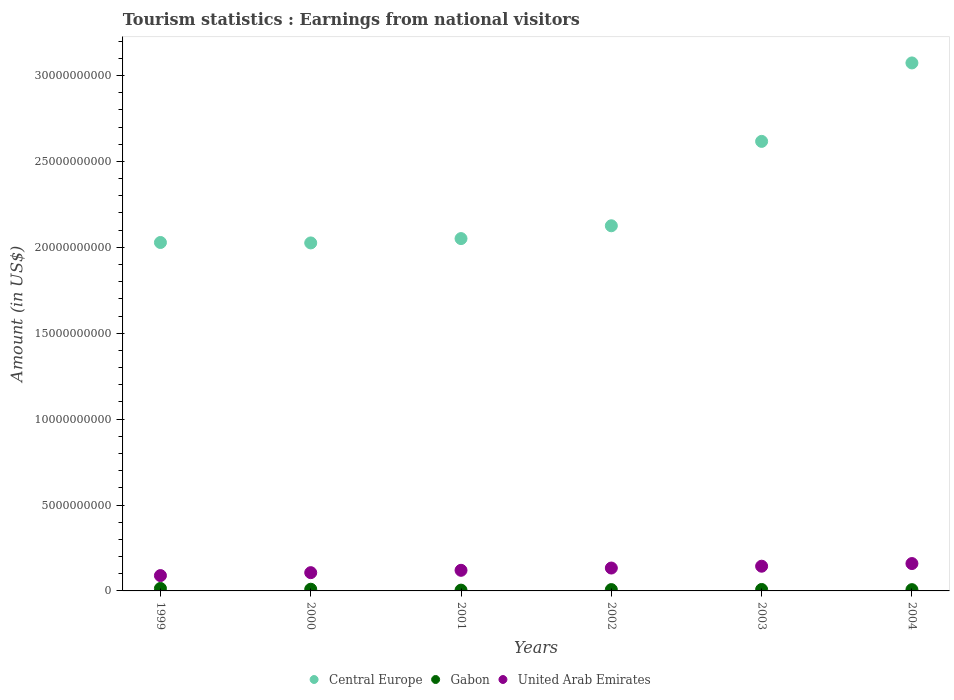What is the earnings from national visitors in Central Europe in 2000?
Make the answer very short. 2.03e+1. Across all years, what is the maximum earnings from national visitors in United Arab Emirates?
Make the answer very short. 1.59e+09. Across all years, what is the minimum earnings from national visitors in Gabon?
Give a very brief answer. 4.60e+07. In which year was the earnings from national visitors in Central Europe maximum?
Give a very brief answer. 2004. What is the total earnings from national visitors in Gabon in the graph?
Your answer should be compact. 5.23e+08. What is the difference between the earnings from national visitors in United Arab Emirates in 2001 and that in 2004?
Provide a succinct answer. -3.93e+08. What is the difference between the earnings from national visitors in Central Europe in 2004 and the earnings from national visitors in United Arab Emirates in 2002?
Provide a succinct answer. 2.94e+1. What is the average earnings from national visitors in Gabon per year?
Offer a very short reply. 8.72e+07. In the year 2002, what is the difference between the earnings from national visitors in Gabon and earnings from national visitors in Central Europe?
Keep it short and to the point. -2.12e+1. What is the ratio of the earnings from national visitors in Central Europe in 2000 to that in 2001?
Give a very brief answer. 0.99. Is the earnings from national visitors in Central Europe in 2000 less than that in 2003?
Your answer should be very brief. Yes. Is the difference between the earnings from national visitors in Gabon in 1999 and 2001 greater than the difference between the earnings from national visitors in Central Europe in 1999 and 2001?
Your response must be concise. Yes. What is the difference between the highest and the second highest earnings from national visitors in Gabon?
Offer a very short reply. 4.40e+07. What is the difference between the highest and the lowest earnings from national visitors in United Arab Emirates?
Your answer should be very brief. 7.00e+08. In how many years, is the earnings from national visitors in Gabon greater than the average earnings from national visitors in Gabon taken over all years?
Give a very brief answer. 2. Is the sum of the earnings from national visitors in Gabon in 2003 and 2004 greater than the maximum earnings from national visitors in Central Europe across all years?
Offer a very short reply. No. Is the earnings from national visitors in Central Europe strictly less than the earnings from national visitors in United Arab Emirates over the years?
Provide a succinct answer. No. How many years are there in the graph?
Ensure brevity in your answer.  6. Are the values on the major ticks of Y-axis written in scientific E-notation?
Make the answer very short. No. How are the legend labels stacked?
Offer a terse response. Horizontal. What is the title of the graph?
Offer a terse response. Tourism statistics : Earnings from national visitors. Does "Fiji" appear as one of the legend labels in the graph?
Give a very brief answer. No. What is the Amount (in US$) of Central Europe in 1999?
Your answer should be compact. 2.03e+1. What is the Amount (in US$) in Gabon in 1999?
Your response must be concise. 1.43e+08. What is the Amount (in US$) of United Arab Emirates in 1999?
Keep it short and to the point. 8.93e+08. What is the Amount (in US$) in Central Europe in 2000?
Make the answer very short. 2.03e+1. What is the Amount (in US$) in Gabon in 2000?
Your answer should be very brief. 9.90e+07. What is the Amount (in US$) in United Arab Emirates in 2000?
Your answer should be compact. 1.06e+09. What is the Amount (in US$) of Central Europe in 2001?
Ensure brevity in your answer.  2.05e+1. What is the Amount (in US$) in Gabon in 2001?
Give a very brief answer. 4.60e+07. What is the Amount (in US$) of United Arab Emirates in 2001?
Your response must be concise. 1.20e+09. What is the Amount (in US$) of Central Europe in 2002?
Your answer should be very brief. 2.13e+1. What is the Amount (in US$) in Gabon in 2002?
Provide a short and direct response. 7.70e+07. What is the Amount (in US$) in United Arab Emirates in 2002?
Provide a succinct answer. 1.33e+09. What is the Amount (in US$) in Central Europe in 2003?
Offer a very short reply. 2.62e+1. What is the Amount (in US$) of Gabon in 2003?
Give a very brief answer. 8.40e+07. What is the Amount (in US$) in United Arab Emirates in 2003?
Your response must be concise. 1.44e+09. What is the Amount (in US$) of Central Europe in 2004?
Your answer should be very brief. 3.07e+1. What is the Amount (in US$) in Gabon in 2004?
Your answer should be very brief. 7.40e+07. What is the Amount (in US$) of United Arab Emirates in 2004?
Your answer should be very brief. 1.59e+09. Across all years, what is the maximum Amount (in US$) in Central Europe?
Make the answer very short. 3.07e+1. Across all years, what is the maximum Amount (in US$) in Gabon?
Offer a terse response. 1.43e+08. Across all years, what is the maximum Amount (in US$) of United Arab Emirates?
Keep it short and to the point. 1.59e+09. Across all years, what is the minimum Amount (in US$) in Central Europe?
Your response must be concise. 2.03e+1. Across all years, what is the minimum Amount (in US$) in Gabon?
Ensure brevity in your answer.  4.60e+07. Across all years, what is the minimum Amount (in US$) of United Arab Emirates?
Provide a succinct answer. 8.93e+08. What is the total Amount (in US$) of Central Europe in the graph?
Give a very brief answer. 1.39e+11. What is the total Amount (in US$) of Gabon in the graph?
Ensure brevity in your answer.  5.23e+08. What is the total Amount (in US$) of United Arab Emirates in the graph?
Ensure brevity in your answer.  7.52e+09. What is the difference between the Amount (in US$) in Central Europe in 1999 and that in 2000?
Ensure brevity in your answer.  2.50e+07. What is the difference between the Amount (in US$) of Gabon in 1999 and that in 2000?
Your answer should be compact. 4.40e+07. What is the difference between the Amount (in US$) in United Arab Emirates in 1999 and that in 2000?
Offer a terse response. -1.70e+08. What is the difference between the Amount (in US$) in Central Europe in 1999 and that in 2001?
Provide a succinct answer. -2.27e+08. What is the difference between the Amount (in US$) of Gabon in 1999 and that in 2001?
Provide a short and direct response. 9.70e+07. What is the difference between the Amount (in US$) in United Arab Emirates in 1999 and that in 2001?
Provide a short and direct response. -3.07e+08. What is the difference between the Amount (in US$) in Central Europe in 1999 and that in 2002?
Your answer should be compact. -9.73e+08. What is the difference between the Amount (in US$) of Gabon in 1999 and that in 2002?
Provide a succinct answer. 6.60e+07. What is the difference between the Amount (in US$) of United Arab Emirates in 1999 and that in 2002?
Your answer should be compact. -4.39e+08. What is the difference between the Amount (in US$) in Central Europe in 1999 and that in 2003?
Your response must be concise. -5.88e+09. What is the difference between the Amount (in US$) of Gabon in 1999 and that in 2003?
Offer a very short reply. 5.90e+07. What is the difference between the Amount (in US$) of United Arab Emirates in 1999 and that in 2003?
Make the answer very short. -5.45e+08. What is the difference between the Amount (in US$) of Central Europe in 1999 and that in 2004?
Your answer should be compact. -1.05e+1. What is the difference between the Amount (in US$) of Gabon in 1999 and that in 2004?
Provide a succinct answer. 6.90e+07. What is the difference between the Amount (in US$) in United Arab Emirates in 1999 and that in 2004?
Provide a short and direct response. -7.00e+08. What is the difference between the Amount (in US$) of Central Europe in 2000 and that in 2001?
Keep it short and to the point. -2.52e+08. What is the difference between the Amount (in US$) in Gabon in 2000 and that in 2001?
Your answer should be very brief. 5.30e+07. What is the difference between the Amount (in US$) in United Arab Emirates in 2000 and that in 2001?
Ensure brevity in your answer.  -1.37e+08. What is the difference between the Amount (in US$) of Central Europe in 2000 and that in 2002?
Provide a short and direct response. -9.98e+08. What is the difference between the Amount (in US$) of Gabon in 2000 and that in 2002?
Give a very brief answer. 2.20e+07. What is the difference between the Amount (in US$) in United Arab Emirates in 2000 and that in 2002?
Keep it short and to the point. -2.69e+08. What is the difference between the Amount (in US$) in Central Europe in 2000 and that in 2003?
Make the answer very short. -5.91e+09. What is the difference between the Amount (in US$) of Gabon in 2000 and that in 2003?
Provide a succinct answer. 1.50e+07. What is the difference between the Amount (in US$) of United Arab Emirates in 2000 and that in 2003?
Provide a succinct answer. -3.75e+08. What is the difference between the Amount (in US$) of Central Europe in 2000 and that in 2004?
Provide a short and direct response. -1.05e+1. What is the difference between the Amount (in US$) in Gabon in 2000 and that in 2004?
Your response must be concise. 2.50e+07. What is the difference between the Amount (in US$) in United Arab Emirates in 2000 and that in 2004?
Your answer should be very brief. -5.30e+08. What is the difference between the Amount (in US$) in Central Europe in 2001 and that in 2002?
Make the answer very short. -7.46e+08. What is the difference between the Amount (in US$) in Gabon in 2001 and that in 2002?
Your answer should be compact. -3.10e+07. What is the difference between the Amount (in US$) of United Arab Emirates in 2001 and that in 2002?
Offer a very short reply. -1.32e+08. What is the difference between the Amount (in US$) of Central Europe in 2001 and that in 2003?
Make the answer very short. -5.66e+09. What is the difference between the Amount (in US$) of Gabon in 2001 and that in 2003?
Provide a succinct answer. -3.80e+07. What is the difference between the Amount (in US$) of United Arab Emirates in 2001 and that in 2003?
Offer a terse response. -2.38e+08. What is the difference between the Amount (in US$) of Central Europe in 2001 and that in 2004?
Keep it short and to the point. -1.02e+1. What is the difference between the Amount (in US$) of Gabon in 2001 and that in 2004?
Ensure brevity in your answer.  -2.80e+07. What is the difference between the Amount (in US$) of United Arab Emirates in 2001 and that in 2004?
Your answer should be very brief. -3.93e+08. What is the difference between the Amount (in US$) of Central Europe in 2002 and that in 2003?
Offer a very short reply. -4.91e+09. What is the difference between the Amount (in US$) of Gabon in 2002 and that in 2003?
Keep it short and to the point. -7.00e+06. What is the difference between the Amount (in US$) of United Arab Emirates in 2002 and that in 2003?
Give a very brief answer. -1.06e+08. What is the difference between the Amount (in US$) in Central Europe in 2002 and that in 2004?
Offer a terse response. -9.48e+09. What is the difference between the Amount (in US$) in Gabon in 2002 and that in 2004?
Make the answer very short. 3.00e+06. What is the difference between the Amount (in US$) in United Arab Emirates in 2002 and that in 2004?
Offer a very short reply. -2.61e+08. What is the difference between the Amount (in US$) in Central Europe in 2003 and that in 2004?
Your answer should be compact. -4.57e+09. What is the difference between the Amount (in US$) in United Arab Emirates in 2003 and that in 2004?
Your response must be concise. -1.55e+08. What is the difference between the Amount (in US$) in Central Europe in 1999 and the Amount (in US$) in Gabon in 2000?
Your response must be concise. 2.02e+1. What is the difference between the Amount (in US$) of Central Europe in 1999 and the Amount (in US$) of United Arab Emirates in 2000?
Offer a terse response. 1.92e+1. What is the difference between the Amount (in US$) in Gabon in 1999 and the Amount (in US$) in United Arab Emirates in 2000?
Make the answer very short. -9.20e+08. What is the difference between the Amount (in US$) of Central Europe in 1999 and the Amount (in US$) of Gabon in 2001?
Keep it short and to the point. 2.02e+1. What is the difference between the Amount (in US$) of Central Europe in 1999 and the Amount (in US$) of United Arab Emirates in 2001?
Offer a very short reply. 1.91e+1. What is the difference between the Amount (in US$) in Gabon in 1999 and the Amount (in US$) in United Arab Emirates in 2001?
Provide a short and direct response. -1.06e+09. What is the difference between the Amount (in US$) of Central Europe in 1999 and the Amount (in US$) of Gabon in 2002?
Make the answer very short. 2.02e+1. What is the difference between the Amount (in US$) in Central Europe in 1999 and the Amount (in US$) in United Arab Emirates in 2002?
Provide a succinct answer. 1.89e+1. What is the difference between the Amount (in US$) in Gabon in 1999 and the Amount (in US$) in United Arab Emirates in 2002?
Keep it short and to the point. -1.19e+09. What is the difference between the Amount (in US$) of Central Europe in 1999 and the Amount (in US$) of Gabon in 2003?
Make the answer very short. 2.02e+1. What is the difference between the Amount (in US$) of Central Europe in 1999 and the Amount (in US$) of United Arab Emirates in 2003?
Your answer should be very brief. 1.88e+1. What is the difference between the Amount (in US$) in Gabon in 1999 and the Amount (in US$) in United Arab Emirates in 2003?
Provide a short and direct response. -1.30e+09. What is the difference between the Amount (in US$) in Central Europe in 1999 and the Amount (in US$) in Gabon in 2004?
Give a very brief answer. 2.02e+1. What is the difference between the Amount (in US$) in Central Europe in 1999 and the Amount (in US$) in United Arab Emirates in 2004?
Provide a succinct answer. 1.87e+1. What is the difference between the Amount (in US$) of Gabon in 1999 and the Amount (in US$) of United Arab Emirates in 2004?
Provide a short and direct response. -1.45e+09. What is the difference between the Amount (in US$) in Central Europe in 2000 and the Amount (in US$) in Gabon in 2001?
Provide a short and direct response. 2.02e+1. What is the difference between the Amount (in US$) in Central Europe in 2000 and the Amount (in US$) in United Arab Emirates in 2001?
Your answer should be compact. 1.91e+1. What is the difference between the Amount (in US$) of Gabon in 2000 and the Amount (in US$) of United Arab Emirates in 2001?
Provide a short and direct response. -1.10e+09. What is the difference between the Amount (in US$) of Central Europe in 2000 and the Amount (in US$) of Gabon in 2002?
Your answer should be compact. 2.02e+1. What is the difference between the Amount (in US$) in Central Europe in 2000 and the Amount (in US$) in United Arab Emirates in 2002?
Offer a very short reply. 1.89e+1. What is the difference between the Amount (in US$) of Gabon in 2000 and the Amount (in US$) of United Arab Emirates in 2002?
Your answer should be very brief. -1.23e+09. What is the difference between the Amount (in US$) of Central Europe in 2000 and the Amount (in US$) of Gabon in 2003?
Your response must be concise. 2.02e+1. What is the difference between the Amount (in US$) in Central Europe in 2000 and the Amount (in US$) in United Arab Emirates in 2003?
Provide a succinct answer. 1.88e+1. What is the difference between the Amount (in US$) in Gabon in 2000 and the Amount (in US$) in United Arab Emirates in 2003?
Offer a very short reply. -1.34e+09. What is the difference between the Amount (in US$) in Central Europe in 2000 and the Amount (in US$) in Gabon in 2004?
Provide a short and direct response. 2.02e+1. What is the difference between the Amount (in US$) of Central Europe in 2000 and the Amount (in US$) of United Arab Emirates in 2004?
Make the answer very short. 1.87e+1. What is the difference between the Amount (in US$) in Gabon in 2000 and the Amount (in US$) in United Arab Emirates in 2004?
Provide a short and direct response. -1.49e+09. What is the difference between the Amount (in US$) in Central Europe in 2001 and the Amount (in US$) in Gabon in 2002?
Provide a succinct answer. 2.04e+1. What is the difference between the Amount (in US$) of Central Europe in 2001 and the Amount (in US$) of United Arab Emirates in 2002?
Provide a succinct answer. 1.92e+1. What is the difference between the Amount (in US$) of Gabon in 2001 and the Amount (in US$) of United Arab Emirates in 2002?
Offer a terse response. -1.29e+09. What is the difference between the Amount (in US$) of Central Europe in 2001 and the Amount (in US$) of Gabon in 2003?
Your response must be concise. 2.04e+1. What is the difference between the Amount (in US$) of Central Europe in 2001 and the Amount (in US$) of United Arab Emirates in 2003?
Offer a terse response. 1.91e+1. What is the difference between the Amount (in US$) of Gabon in 2001 and the Amount (in US$) of United Arab Emirates in 2003?
Make the answer very short. -1.39e+09. What is the difference between the Amount (in US$) of Central Europe in 2001 and the Amount (in US$) of Gabon in 2004?
Provide a short and direct response. 2.04e+1. What is the difference between the Amount (in US$) in Central Europe in 2001 and the Amount (in US$) in United Arab Emirates in 2004?
Ensure brevity in your answer.  1.89e+1. What is the difference between the Amount (in US$) of Gabon in 2001 and the Amount (in US$) of United Arab Emirates in 2004?
Make the answer very short. -1.55e+09. What is the difference between the Amount (in US$) of Central Europe in 2002 and the Amount (in US$) of Gabon in 2003?
Ensure brevity in your answer.  2.12e+1. What is the difference between the Amount (in US$) of Central Europe in 2002 and the Amount (in US$) of United Arab Emirates in 2003?
Keep it short and to the point. 1.98e+1. What is the difference between the Amount (in US$) of Gabon in 2002 and the Amount (in US$) of United Arab Emirates in 2003?
Your answer should be compact. -1.36e+09. What is the difference between the Amount (in US$) of Central Europe in 2002 and the Amount (in US$) of Gabon in 2004?
Ensure brevity in your answer.  2.12e+1. What is the difference between the Amount (in US$) in Central Europe in 2002 and the Amount (in US$) in United Arab Emirates in 2004?
Provide a succinct answer. 1.97e+1. What is the difference between the Amount (in US$) in Gabon in 2002 and the Amount (in US$) in United Arab Emirates in 2004?
Give a very brief answer. -1.52e+09. What is the difference between the Amount (in US$) of Central Europe in 2003 and the Amount (in US$) of Gabon in 2004?
Your answer should be compact. 2.61e+1. What is the difference between the Amount (in US$) in Central Europe in 2003 and the Amount (in US$) in United Arab Emirates in 2004?
Make the answer very short. 2.46e+1. What is the difference between the Amount (in US$) in Gabon in 2003 and the Amount (in US$) in United Arab Emirates in 2004?
Your answer should be compact. -1.51e+09. What is the average Amount (in US$) in Central Europe per year?
Provide a succinct answer. 2.32e+1. What is the average Amount (in US$) in Gabon per year?
Your response must be concise. 8.72e+07. What is the average Amount (in US$) of United Arab Emirates per year?
Your answer should be very brief. 1.25e+09. In the year 1999, what is the difference between the Amount (in US$) in Central Europe and Amount (in US$) in Gabon?
Ensure brevity in your answer.  2.01e+1. In the year 1999, what is the difference between the Amount (in US$) in Central Europe and Amount (in US$) in United Arab Emirates?
Ensure brevity in your answer.  1.94e+1. In the year 1999, what is the difference between the Amount (in US$) of Gabon and Amount (in US$) of United Arab Emirates?
Ensure brevity in your answer.  -7.50e+08. In the year 2000, what is the difference between the Amount (in US$) of Central Europe and Amount (in US$) of Gabon?
Give a very brief answer. 2.02e+1. In the year 2000, what is the difference between the Amount (in US$) in Central Europe and Amount (in US$) in United Arab Emirates?
Offer a very short reply. 1.92e+1. In the year 2000, what is the difference between the Amount (in US$) of Gabon and Amount (in US$) of United Arab Emirates?
Give a very brief answer. -9.64e+08. In the year 2001, what is the difference between the Amount (in US$) of Central Europe and Amount (in US$) of Gabon?
Your response must be concise. 2.05e+1. In the year 2001, what is the difference between the Amount (in US$) of Central Europe and Amount (in US$) of United Arab Emirates?
Give a very brief answer. 1.93e+1. In the year 2001, what is the difference between the Amount (in US$) of Gabon and Amount (in US$) of United Arab Emirates?
Your answer should be compact. -1.15e+09. In the year 2002, what is the difference between the Amount (in US$) in Central Europe and Amount (in US$) in Gabon?
Give a very brief answer. 2.12e+1. In the year 2002, what is the difference between the Amount (in US$) in Central Europe and Amount (in US$) in United Arab Emirates?
Provide a short and direct response. 1.99e+1. In the year 2002, what is the difference between the Amount (in US$) of Gabon and Amount (in US$) of United Arab Emirates?
Your answer should be compact. -1.26e+09. In the year 2003, what is the difference between the Amount (in US$) in Central Europe and Amount (in US$) in Gabon?
Your answer should be very brief. 2.61e+1. In the year 2003, what is the difference between the Amount (in US$) of Central Europe and Amount (in US$) of United Arab Emirates?
Your answer should be compact. 2.47e+1. In the year 2003, what is the difference between the Amount (in US$) of Gabon and Amount (in US$) of United Arab Emirates?
Give a very brief answer. -1.35e+09. In the year 2004, what is the difference between the Amount (in US$) in Central Europe and Amount (in US$) in Gabon?
Your answer should be compact. 3.07e+1. In the year 2004, what is the difference between the Amount (in US$) of Central Europe and Amount (in US$) of United Arab Emirates?
Provide a succinct answer. 2.91e+1. In the year 2004, what is the difference between the Amount (in US$) in Gabon and Amount (in US$) in United Arab Emirates?
Make the answer very short. -1.52e+09. What is the ratio of the Amount (in US$) in Gabon in 1999 to that in 2000?
Your response must be concise. 1.44. What is the ratio of the Amount (in US$) of United Arab Emirates in 1999 to that in 2000?
Provide a succinct answer. 0.84. What is the ratio of the Amount (in US$) of Central Europe in 1999 to that in 2001?
Keep it short and to the point. 0.99. What is the ratio of the Amount (in US$) of Gabon in 1999 to that in 2001?
Make the answer very short. 3.11. What is the ratio of the Amount (in US$) of United Arab Emirates in 1999 to that in 2001?
Give a very brief answer. 0.74. What is the ratio of the Amount (in US$) in Central Europe in 1999 to that in 2002?
Provide a short and direct response. 0.95. What is the ratio of the Amount (in US$) in Gabon in 1999 to that in 2002?
Offer a very short reply. 1.86. What is the ratio of the Amount (in US$) of United Arab Emirates in 1999 to that in 2002?
Provide a succinct answer. 0.67. What is the ratio of the Amount (in US$) of Central Europe in 1999 to that in 2003?
Your answer should be very brief. 0.78. What is the ratio of the Amount (in US$) in Gabon in 1999 to that in 2003?
Offer a terse response. 1.7. What is the ratio of the Amount (in US$) in United Arab Emirates in 1999 to that in 2003?
Offer a very short reply. 0.62. What is the ratio of the Amount (in US$) of Central Europe in 1999 to that in 2004?
Make the answer very short. 0.66. What is the ratio of the Amount (in US$) in Gabon in 1999 to that in 2004?
Your response must be concise. 1.93. What is the ratio of the Amount (in US$) of United Arab Emirates in 1999 to that in 2004?
Give a very brief answer. 0.56. What is the ratio of the Amount (in US$) in Central Europe in 2000 to that in 2001?
Offer a very short reply. 0.99. What is the ratio of the Amount (in US$) of Gabon in 2000 to that in 2001?
Provide a succinct answer. 2.15. What is the ratio of the Amount (in US$) of United Arab Emirates in 2000 to that in 2001?
Your answer should be very brief. 0.89. What is the ratio of the Amount (in US$) in Central Europe in 2000 to that in 2002?
Make the answer very short. 0.95. What is the ratio of the Amount (in US$) in Gabon in 2000 to that in 2002?
Your answer should be very brief. 1.29. What is the ratio of the Amount (in US$) of United Arab Emirates in 2000 to that in 2002?
Your response must be concise. 0.8. What is the ratio of the Amount (in US$) of Central Europe in 2000 to that in 2003?
Provide a short and direct response. 0.77. What is the ratio of the Amount (in US$) of Gabon in 2000 to that in 2003?
Offer a terse response. 1.18. What is the ratio of the Amount (in US$) of United Arab Emirates in 2000 to that in 2003?
Your answer should be compact. 0.74. What is the ratio of the Amount (in US$) of Central Europe in 2000 to that in 2004?
Ensure brevity in your answer.  0.66. What is the ratio of the Amount (in US$) in Gabon in 2000 to that in 2004?
Give a very brief answer. 1.34. What is the ratio of the Amount (in US$) of United Arab Emirates in 2000 to that in 2004?
Offer a very short reply. 0.67. What is the ratio of the Amount (in US$) of Central Europe in 2001 to that in 2002?
Give a very brief answer. 0.96. What is the ratio of the Amount (in US$) in Gabon in 2001 to that in 2002?
Your response must be concise. 0.6. What is the ratio of the Amount (in US$) of United Arab Emirates in 2001 to that in 2002?
Keep it short and to the point. 0.9. What is the ratio of the Amount (in US$) in Central Europe in 2001 to that in 2003?
Give a very brief answer. 0.78. What is the ratio of the Amount (in US$) of Gabon in 2001 to that in 2003?
Give a very brief answer. 0.55. What is the ratio of the Amount (in US$) of United Arab Emirates in 2001 to that in 2003?
Offer a very short reply. 0.83. What is the ratio of the Amount (in US$) in Central Europe in 2001 to that in 2004?
Offer a very short reply. 0.67. What is the ratio of the Amount (in US$) of Gabon in 2001 to that in 2004?
Offer a terse response. 0.62. What is the ratio of the Amount (in US$) of United Arab Emirates in 2001 to that in 2004?
Offer a very short reply. 0.75. What is the ratio of the Amount (in US$) in Central Europe in 2002 to that in 2003?
Offer a very short reply. 0.81. What is the ratio of the Amount (in US$) of Gabon in 2002 to that in 2003?
Your answer should be compact. 0.92. What is the ratio of the Amount (in US$) of United Arab Emirates in 2002 to that in 2003?
Your answer should be compact. 0.93. What is the ratio of the Amount (in US$) of Central Europe in 2002 to that in 2004?
Provide a succinct answer. 0.69. What is the ratio of the Amount (in US$) in Gabon in 2002 to that in 2004?
Provide a short and direct response. 1.04. What is the ratio of the Amount (in US$) in United Arab Emirates in 2002 to that in 2004?
Keep it short and to the point. 0.84. What is the ratio of the Amount (in US$) in Central Europe in 2003 to that in 2004?
Your response must be concise. 0.85. What is the ratio of the Amount (in US$) of Gabon in 2003 to that in 2004?
Your answer should be very brief. 1.14. What is the ratio of the Amount (in US$) in United Arab Emirates in 2003 to that in 2004?
Offer a terse response. 0.9. What is the difference between the highest and the second highest Amount (in US$) in Central Europe?
Your answer should be very brief. 4.57e+09. What is the difference between the highest and the second highest Amount (in US$) in Gabon?
Keep it short and to the point. 4.40e+07. What is the difference between the highest and the second highest Amount (in US$) in United Arab Emirates?
Provide a short and direct response. 1.55e+08. What is the difference between the highest and the lowest Amount (in US$) of Central Europe?
Provide a short and direct response. 1.05e+1. What is the difference between the highest and the lowest Amount (in US$) of Gabon?
Give a very brief answer. 9.70e+07. What is the difference between the highest and the lowest Amount (in US$) in United Arab Emirates?
Offer a very short reply. 7.00e+08. 